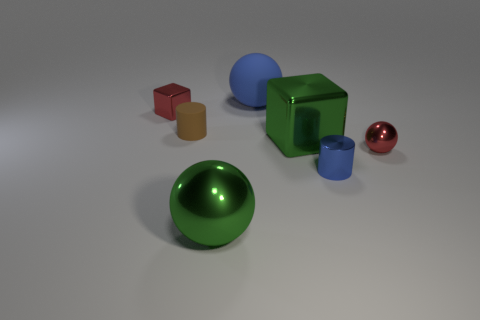There is a green sphere that is the same size as the blue rubber object; what material is it?
Keep it short and to the point. Metal. There is a red sphere that is made of the same material as the green ball; what size is it?
Make the answer very short. Small. What material is the red thing to the right of the red metallic object that is to the left of the large green thing in front of the blue metal cylinder?
Your answer should be compact. Metal. Does the small blue cylinder have the same material as the large object behind the big block?
Ensure brevity in your answer.  No. What material is the big green thing that is the same shape as the blue matte thing?
Your answer should be compact. Metal. Are there any other things that have the same material as the tiny ball?
Your answer should be compact. Yes. Are there more cylinders right of the small red sphere than tiny brown rubber cylinders that are right of the big shiny ball?
Provide a succinct answer. No. There is a small thing that is the same material as the large blue ball; what is its shape?
Offer a very short reply. Cylinder. How many other things are there of the same shape as the small matte object?
Keep it short and to the point. 1. What shape is the big green shiny object that is left of the big blue matte object?
Make the answer very short. Sphere. 